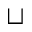<formula> <loc_0><loc_0><loc_500><loc_500>\sqcup</formula> 